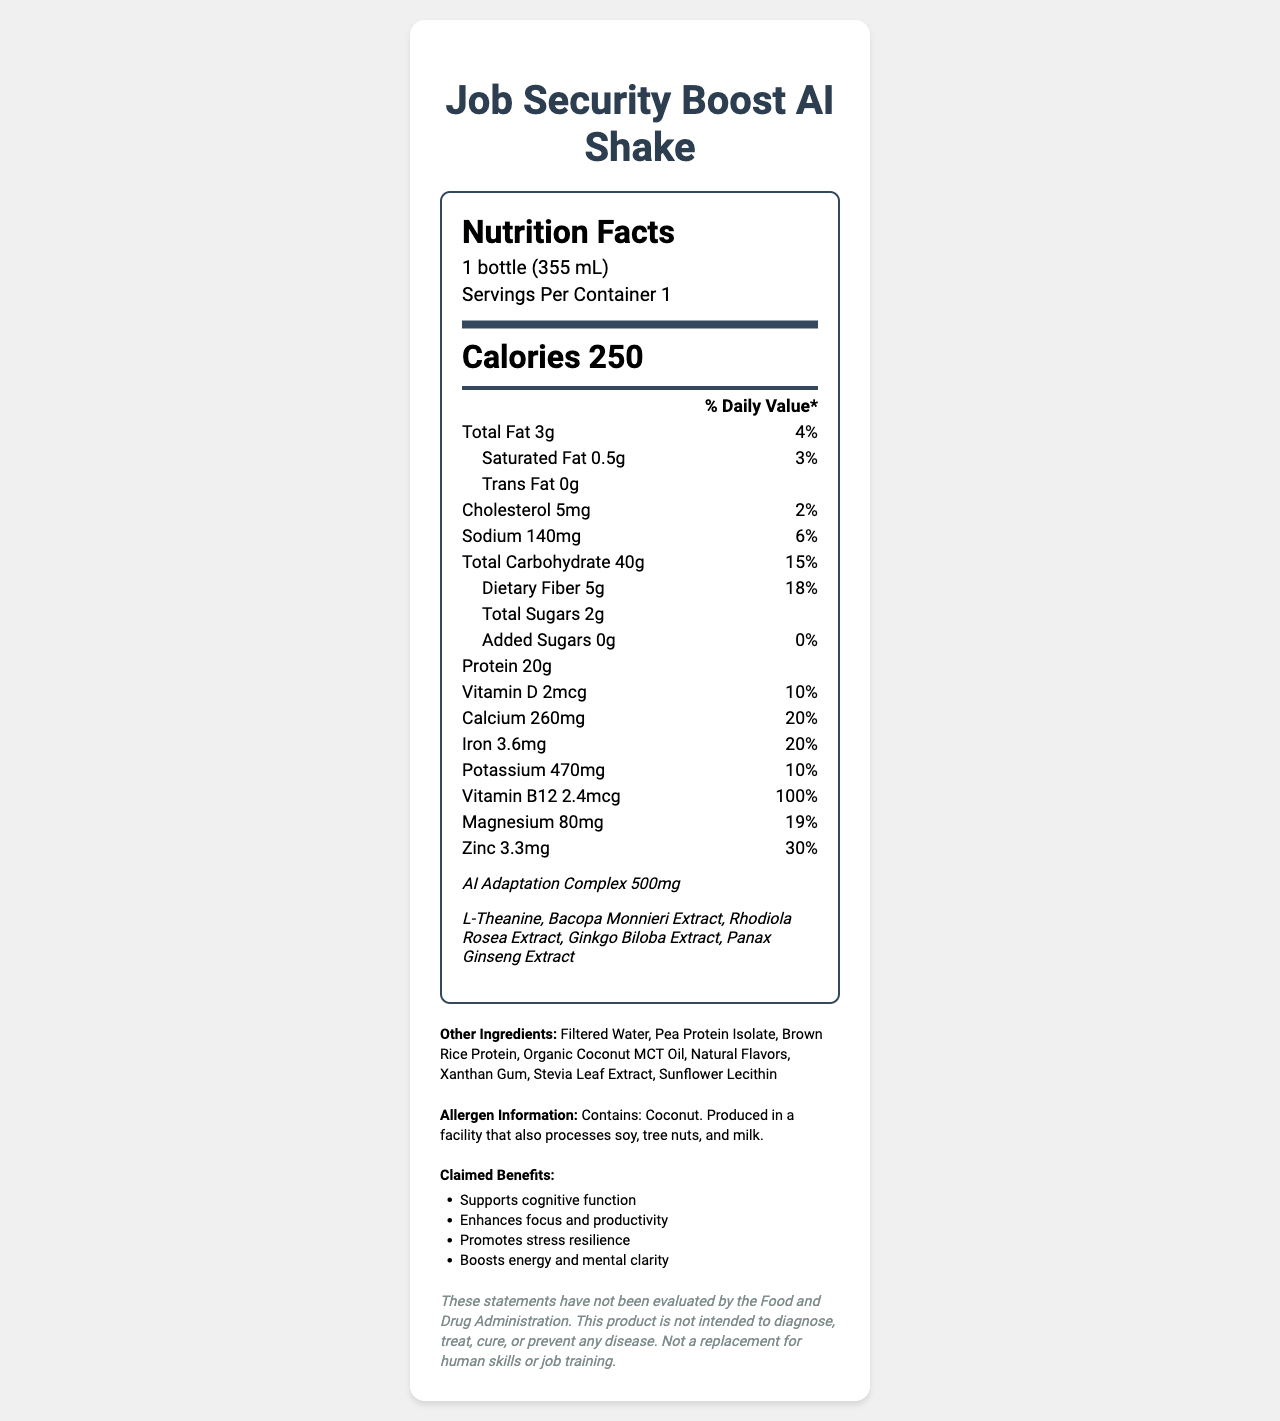what is the serving size of the Job Security Boost AI Shake? The serving size is stated clearly at the top of the label as "1 bottle (355 mL)".
Answer: 1 bottle (355 mL) how many grams of protein are there per serving? The protein content is listed under the nutrients section as "Protein 20g".
Answer: 20g what is the percentage daily value of dietary fiber? The daily value percentage for dietary fiber is given in the document as "dietary fiber 5g, 18%".
Answer: 18% what are the ingredients present in the proprietary blend? These ingredients are listed under the "proprietary blend" section as part of the AI Adaptation Complex.
Answer: L-Theanine, Bacopa Monnieri Extract, Rhodiola Rosea Extract, Ginkgo Biloba Extract, Panax Ginseng Extract how much vitamin B12 does one serving provide? The vitamin B12 content is detailed in the nutrients section as "vitamin B12 2.4mcg".
Answer: 2.4mcg what are the primary claimed benefits of the Job Security Boost AI Shake? These benefits are explicitly listed under the claimed benefits section.
Answer: Supports cognitive function, Enhances focus and productivity, Promotes stress resilience, Boosts energy and mental clarity which of the following vitamins and minerals has the highest daily value percentage in the shake? (A) Calcium (B) Iron (C) Vitamin B12 (D) Magnesium Vitamin B12 has a 100% daily value, which is the highest among the listed vitamins and minerals.
Answer: C. Vitamin B12 how many grams of total fat and saturated fat are there in one serving? (i) 4g and 2g (ii) 3g and 0.5g (iii) 3g and 1g The document lists "total fat 3g" and "saturated fat 0.5g".
Answer: (ii) 3g and 0.5g does this product contain any added sugars? The nutrition label states that there are 0g of added sugars.
Answer: No is the shake suitable for people with coconut allergies? The allergen info clearly states "Contains: Coconut."
Answer: No summarize the key nutritional details and benefits of the Job Security Boost AI Shake. The shake's main nutritional details, including protein and fiber content, along with its unique blend of cognitive support ingredients, are highlighted. Additionally, the benefits promoting mental and physical performance are summarized.
Answer: The Job Security Boost AI Shake provides 250 calories per 355 mL bottle. It contains 20g of protein, 5g of dietary fiber, and various vitamins and minerals such as 260 mg of calcium and 2.4 mcg of vitamin B12. The shake is also infused with an AI Adaptation Complex containing ingredients known for cognitive support. Its claimed benefits include enhanced focus, productivity, stress resilience, and energy. does this shake help to diagnose, treat, cure, or prevent any disease? The disclaimer in the document states that the product is not intended to diagnose, treat, cure, or prevent any disease.
Answer: No what is the specific manufacturing process for the AI Adaptation Complex? The document does not provide details on the manufacturing process of the AI Adaptation Complex.
Answer: Not enough information 